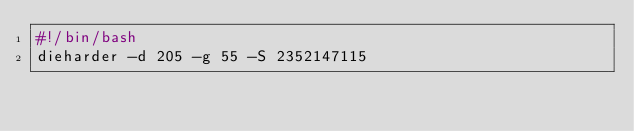<code> <loc_0><loc_0><loc_500><loc_500><_Bash_>#!/bin/bash
dieharder -d 205 -g 55 -S 2352147115
</code> 